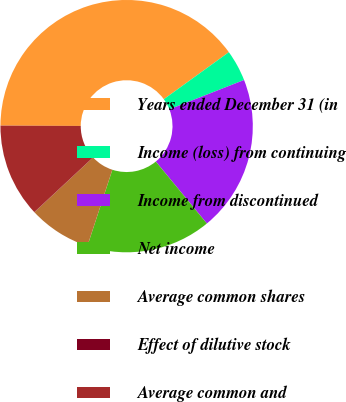Convert chart to OTSL. <chart><loc_0><loc_0><loc_500><loc_500><pie_chart><fcel>Years ended December 31 (in<fcel>Income (loss) from continuing<fcel>Income from discontinued<fcel>Net income<fcel>Average common shares<fcel>Effect of dilutive stock<fcel>Average common and<nl><fcel>39.97%<fcel>4.01%<fcel>19.99%<fcel>16.0%<fcel>8.01%<fcel>0.02%<fcel>12.0%<nl></chart> 